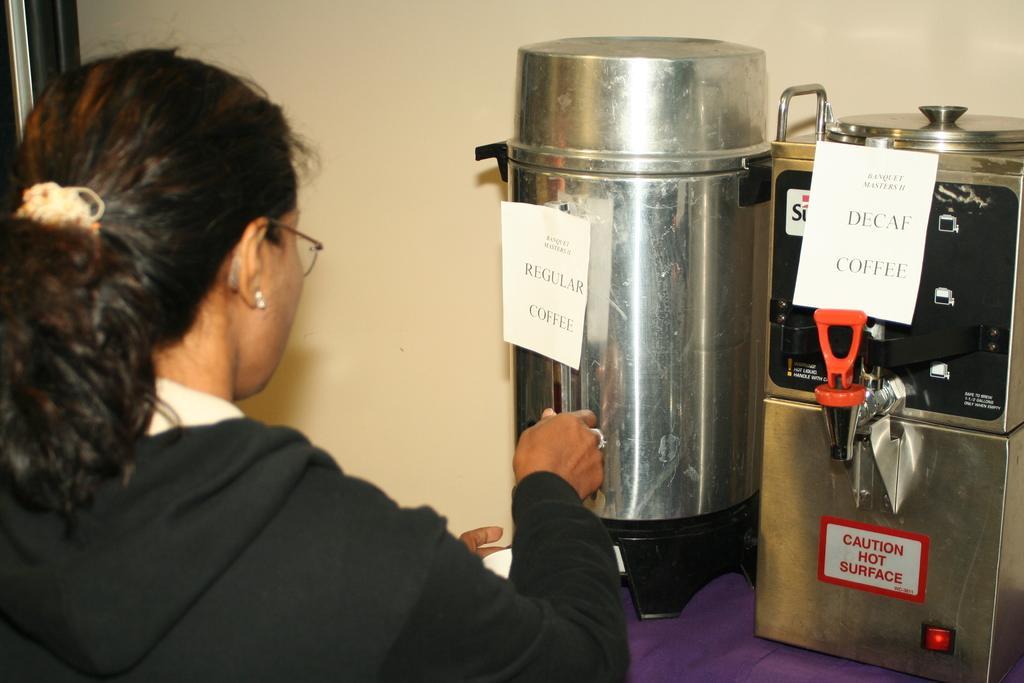Describe this image in one or two sentences. In this picture I can see a woman in front who is wearing black color dress and I see 2 equipment in front of her, on which there are papers and I see something is written on them. In the background I see the wall. 